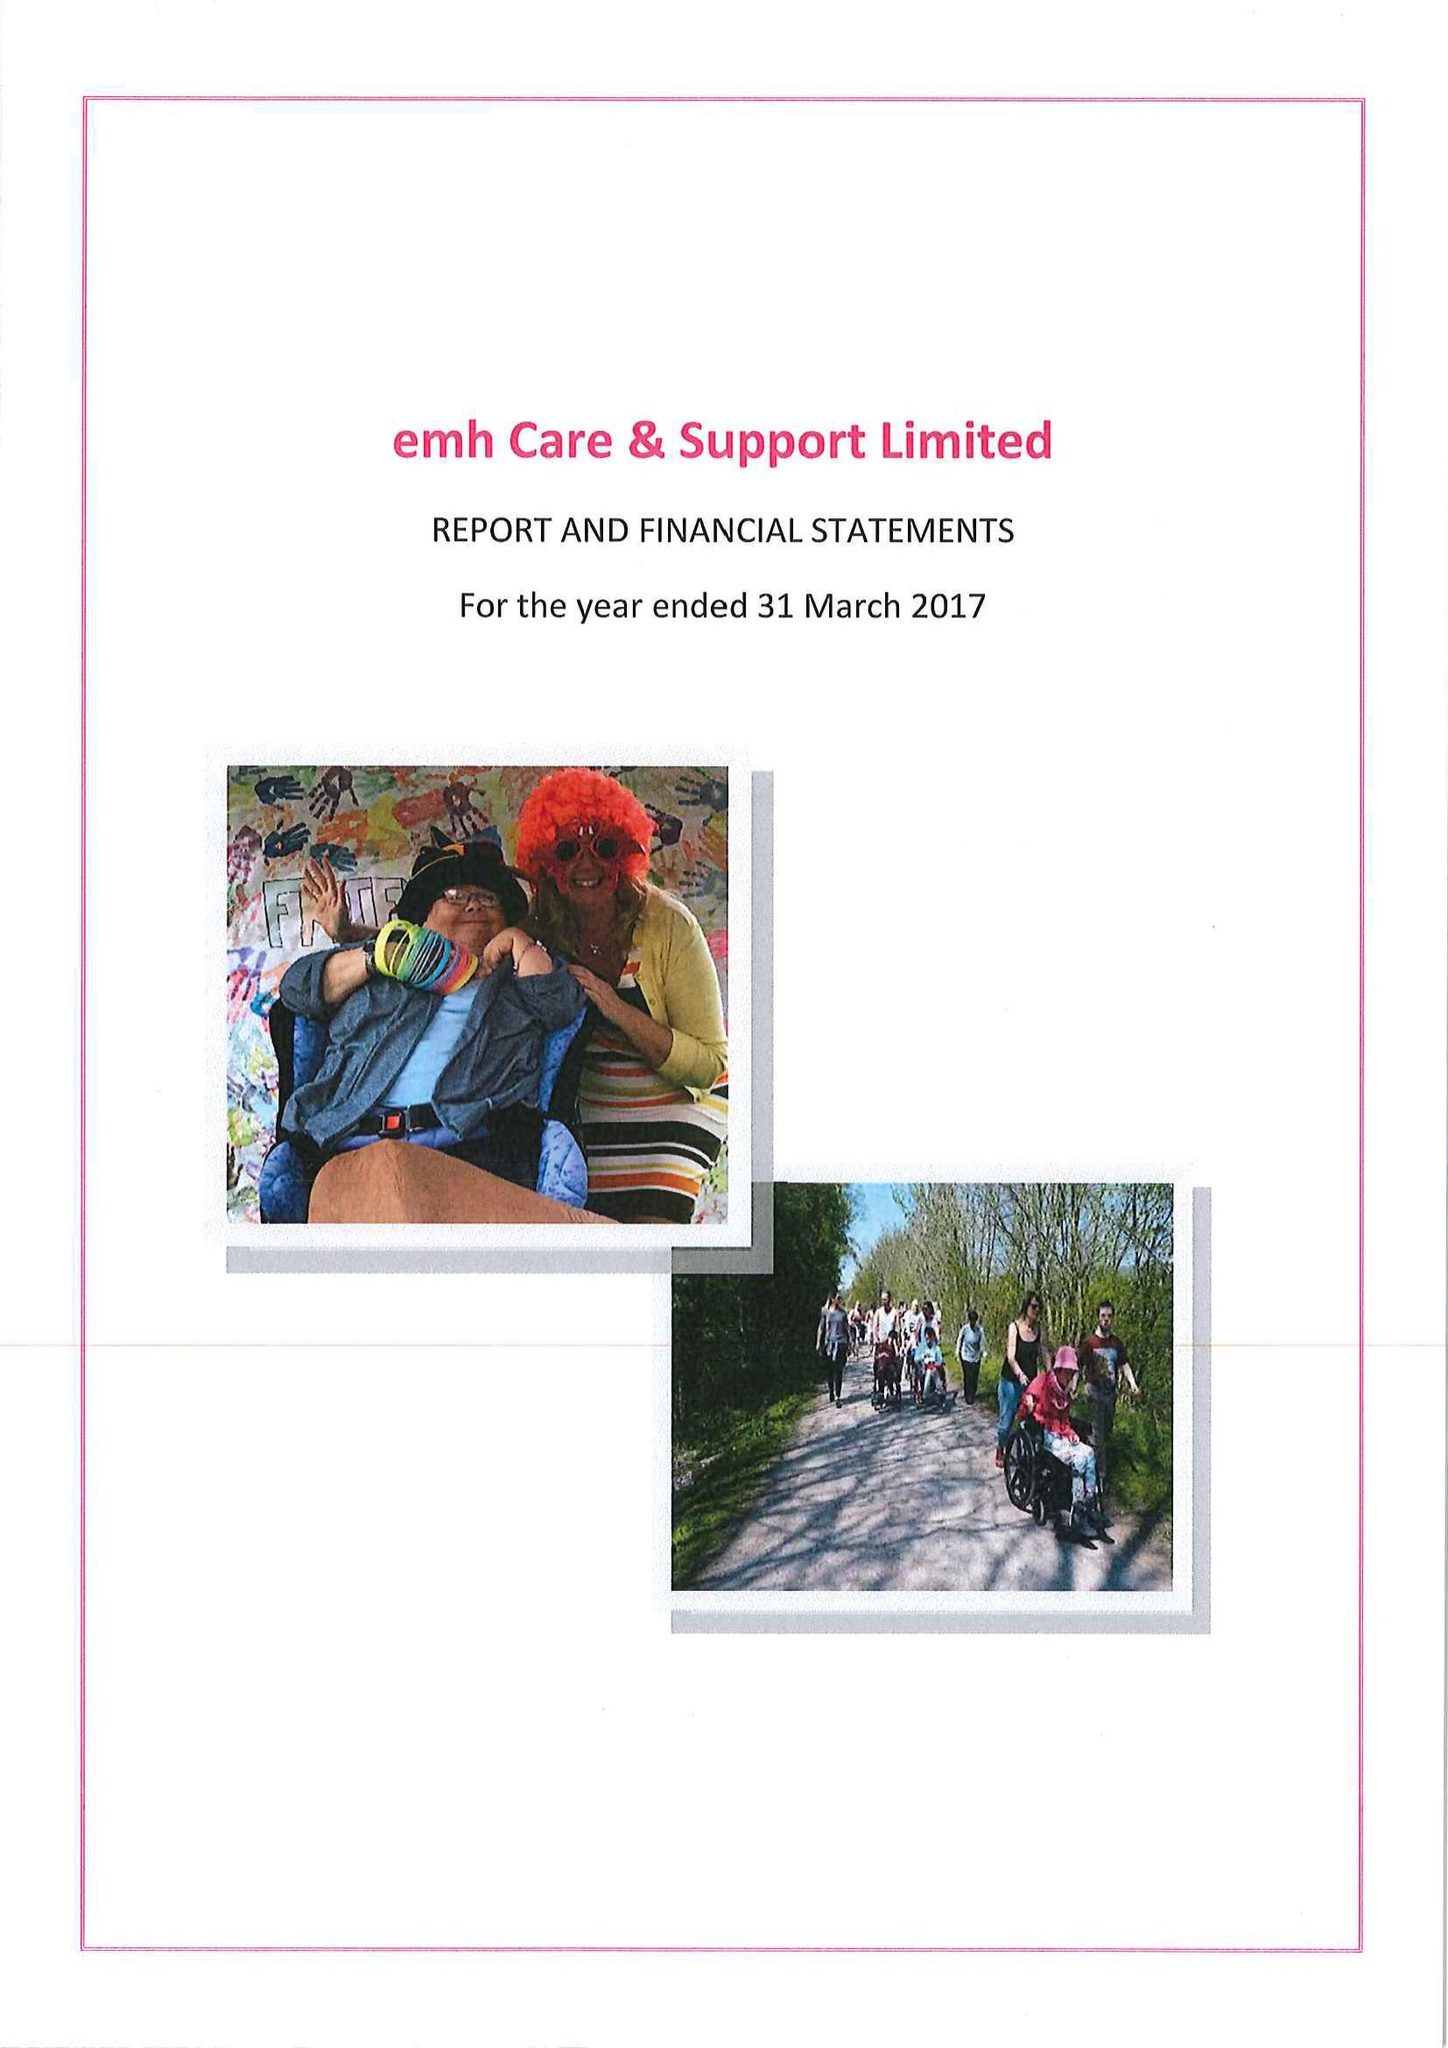What is the value for the income_annually_in_british_pounds?
Answer the question using a single word or phrase. 15257629.00 